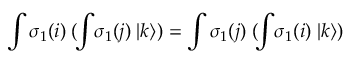Convert formula to latex. <formula><loc_0><loc_0><loc_500><loc_500>\int \sigma _ { 1 } ( i ) \, ( \, \int \, \sigma _ { 1 } ( j ) \, | k \rangle ) = \int \sigma _ { 1 } ( j ) \, ( \, \int \, \sigma _ { 1 } ( i ) \, | k \rangle )</formula> 